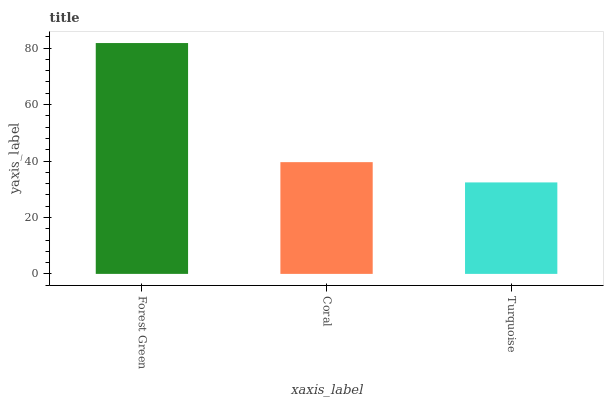Is Turquoise the minimum?
Answer yes or no. Yes. Is Forest Green the maximum?
Answer yes or no. Yes. Is Coral the minimum?
Answer yes or no. No. Is Coral the maximum?
Answer yes or no. No. Is Forest Green greater than Coral?
Answer yes or no. Yes. Is Coral less than Forest Green?
Answer yes or no. Yes. Is Coral greater than Forest Green?
Answer yes or no. No. Is Forest Green less than Coral?
Answer yes or no. No. Is Coral the high median?
Answer yes or no. Yes. Is Coral the low median?
Answer yes or no. Yes. Is Turquoise the high median?
Answer yes or no. No. Is Turquoise the low median?
Answer yes or no. No. 